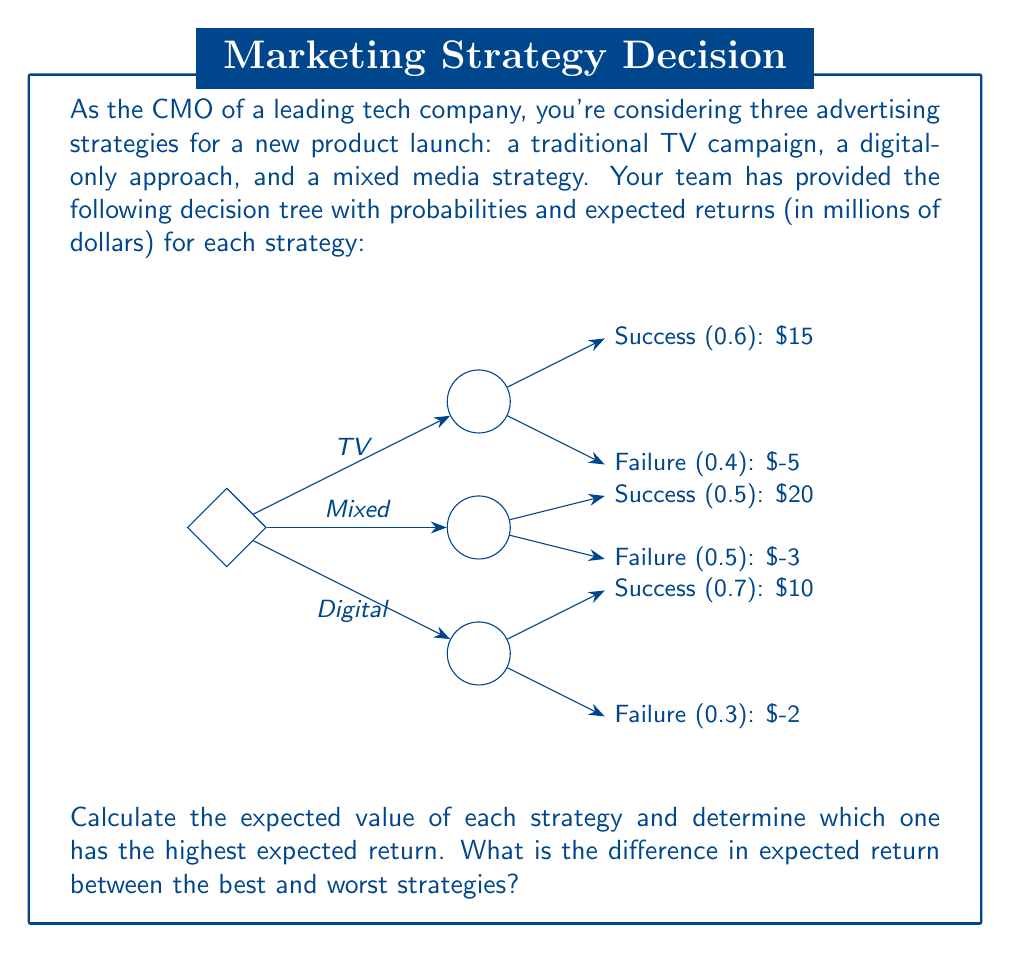Show me your answer to this math problem. Let's calculate the expected value (EV) for each strategy:

1. TV Campaign:
   $$EV_{TV} = 0.6 \times 15 + 0.4 \times (-5) = 9 - 2 = 7$$

2. Digital-only Approach:
   $$EV_{Digital} = 0.7 \times 10 + 0.3 \times (-2) = 7 - 0.6 = 6.4$$

3. Mixed Media Strategy:
   $$EV_{Mixed} = 0.5 \times 20 + 0.5 \times (-3) = 10 - 1.5 = 8.5$$

The strategy with the highest expected return is the Mixed Media Strategy with an expected value of $8.5 million.

The strategy with the lowest expected return is the Digital-only Approach with an expected value of $6.4 million.

To find the difference between the best and worst strategies:

$$Difference = EV_{Mixed} - EV_{Digital} = 8.5 - 6.4 = 2.1$$
Answer: The difference in expected return between the best strategy (Mixed Media) and the worst strategy (Digital-only) is $2.1 million. 